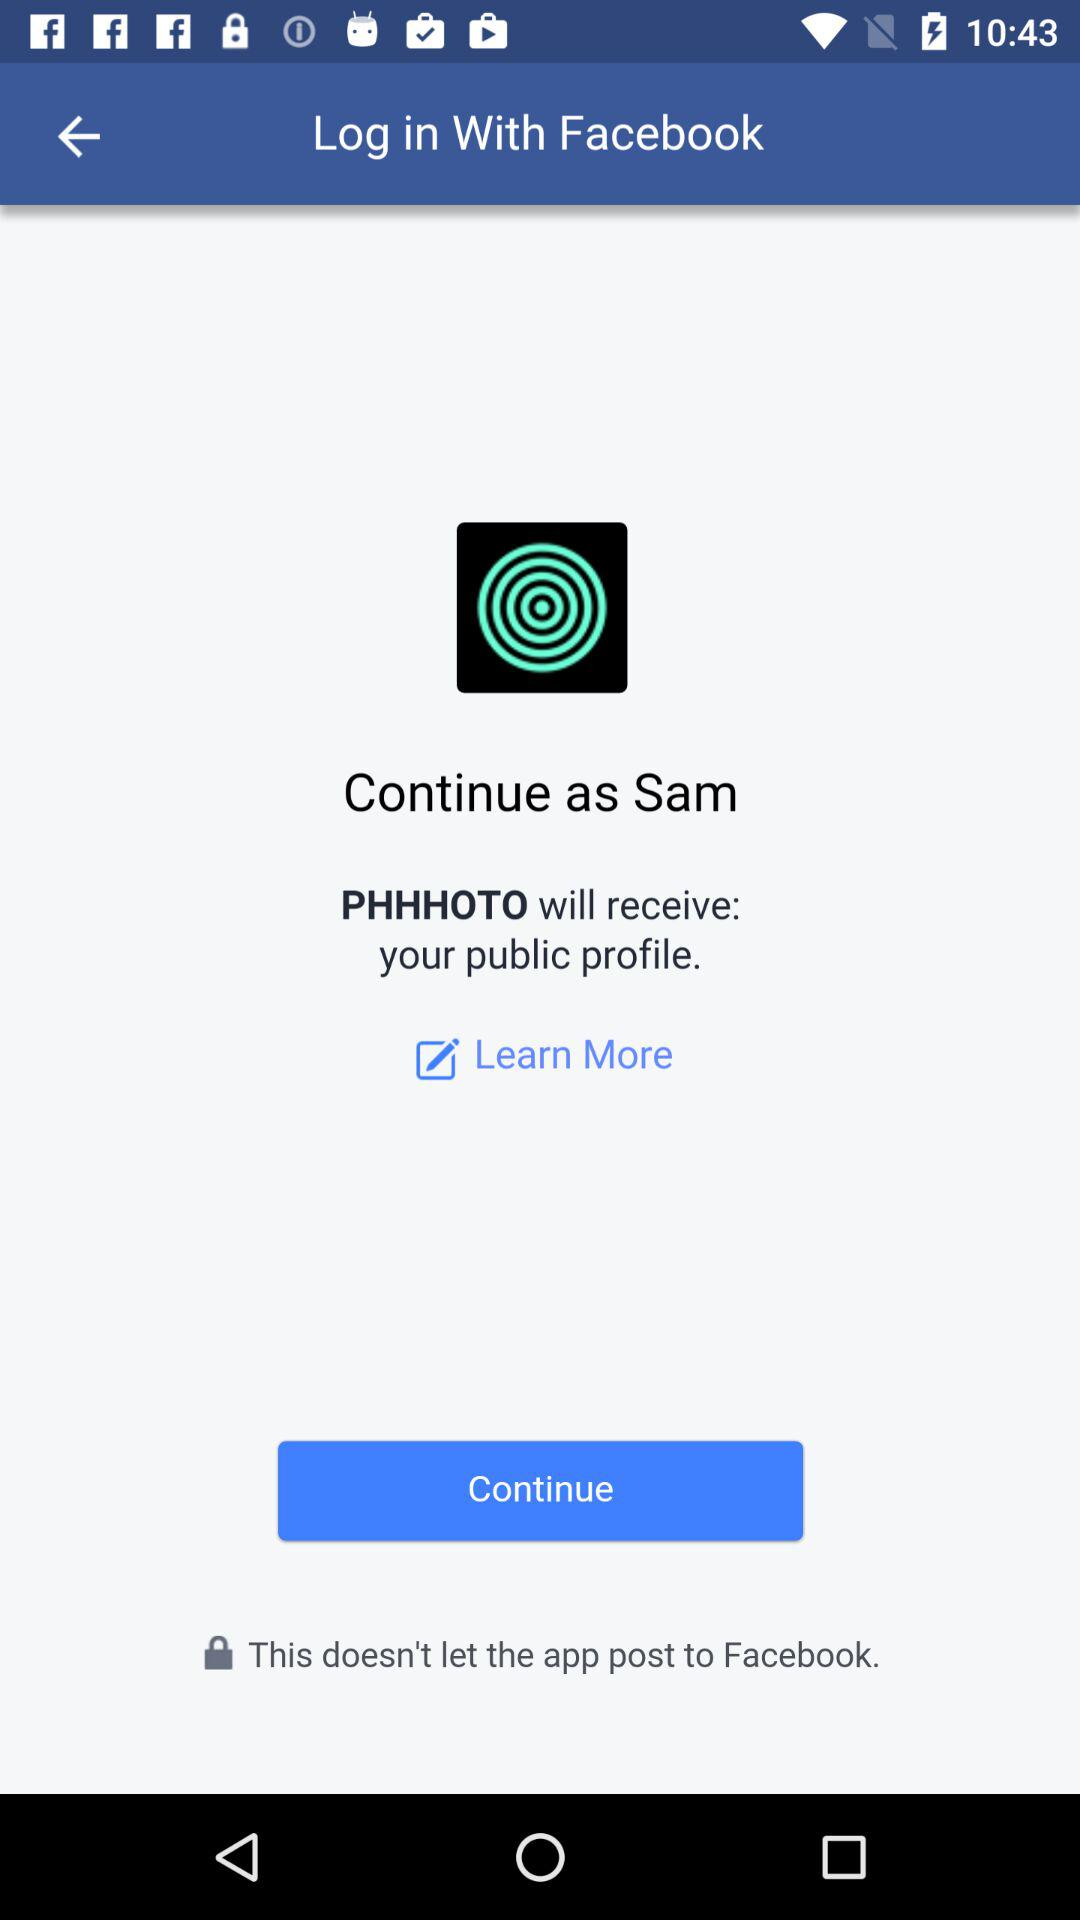What is the definition of "Learn More"?
When the provided information is insufficient, respond with <no answer>. <no answer> 